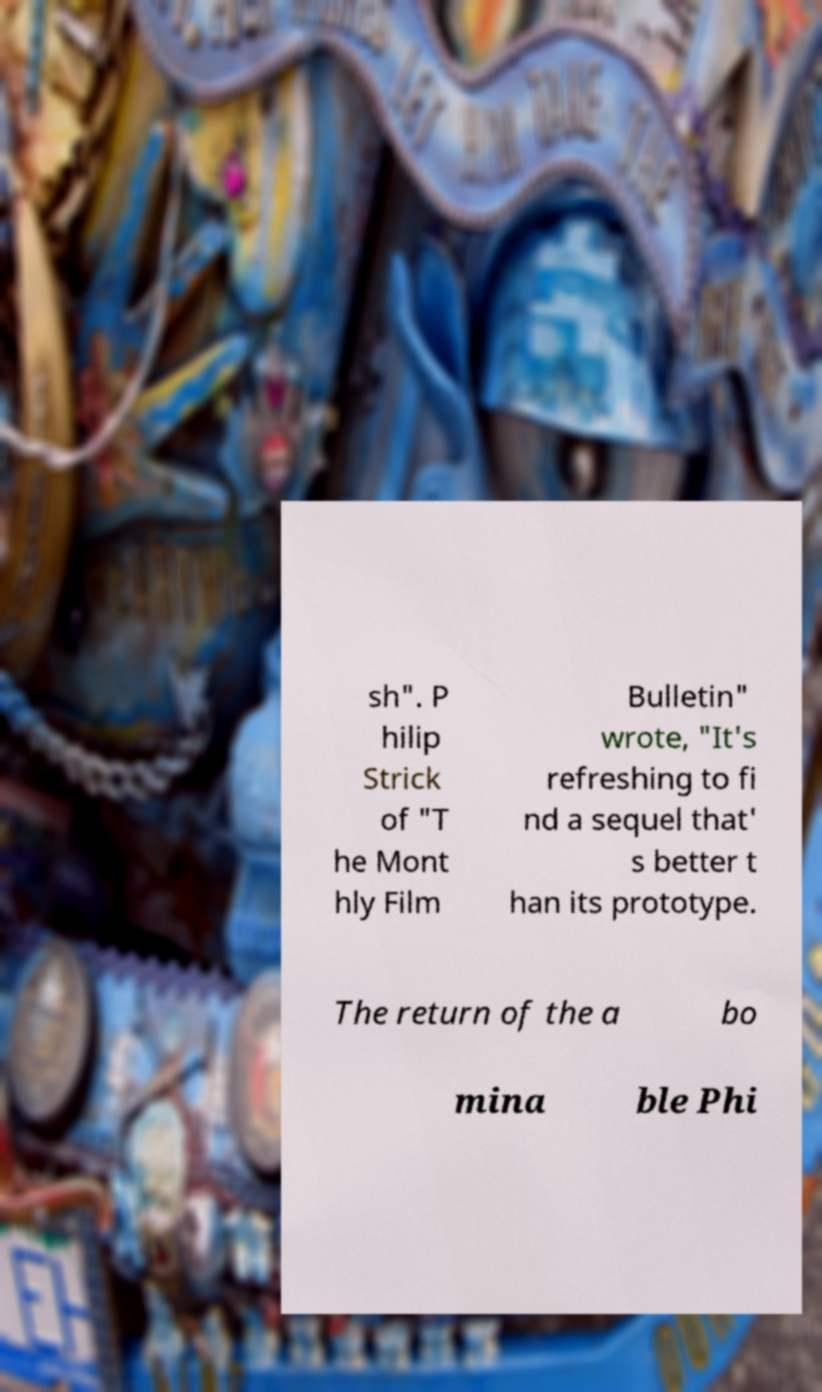Please read and relay the text visible in this image. What does it say? sh". P hilip Strick of "T he Mont hly Film Bulletin" wrote, "It's refreshing to fi nd a sequel that' s better t han its prototype. The return of the a bo mina ble Phi 